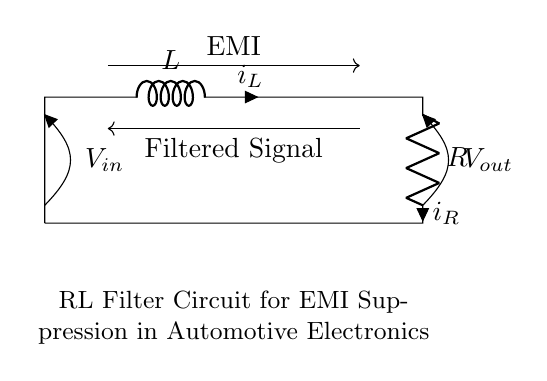What components are present in this circuit? The circuit contains an inductor and a resistor, as indicated by the symbols L and R respectively.
Answer: Inductor, Resistor What is the input voltage of the circuit represented as? The input voltage is represented as V_in, which is shown at the top left of the circuit diagram.
Answer: V_in What is the purpose of this RL filter circuit? The circuit's purpose is to suppress electromagnetic interference, as stated in the description below the circuit.
Answer: EMI suppression What is the type of filter created by this RL circuit configuration? This circuit acts as a low-pass filter, allowing low-frequency signals to pass while attenuating higher frequencies, typical of RL filters.
Answer: Low-pass filter What is the current direction for the inductor in the circuit? The current through the inductor, represented as i_L, flows from the top through the inductor down towards the resistor.
Answer: Downward Why does this circuit mitigate electromagnetic interference? The combination of the resistor and inductor allows the circuit to impede high-frequency noise while permitting desired low-frequency signals to pass. This results in reduced EMI affecting automotive electronics.
Answer: Reduces EMI How does the output voltage relate to the input voltage in this RL circuit? The output voltage V_out is taken across the resistor, and due to the inductor's impedance to high frequency, it indicates that V_out will be less than V_in for high-frequency components.
Answer: V_out < V_in for high frequencies 